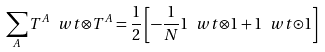<formula> <loc_0><loc_0><loc_500><loc_500>\sum _ { A } T ^ { A } \ w t { \otimes } T ^ { A } = \frac { 1 } { 2 } \left [ - \frac { 1 } { N } 1 \ w t { \otimes } 1 + 1 \ w t { \odot } 1 \right ]</formula> 